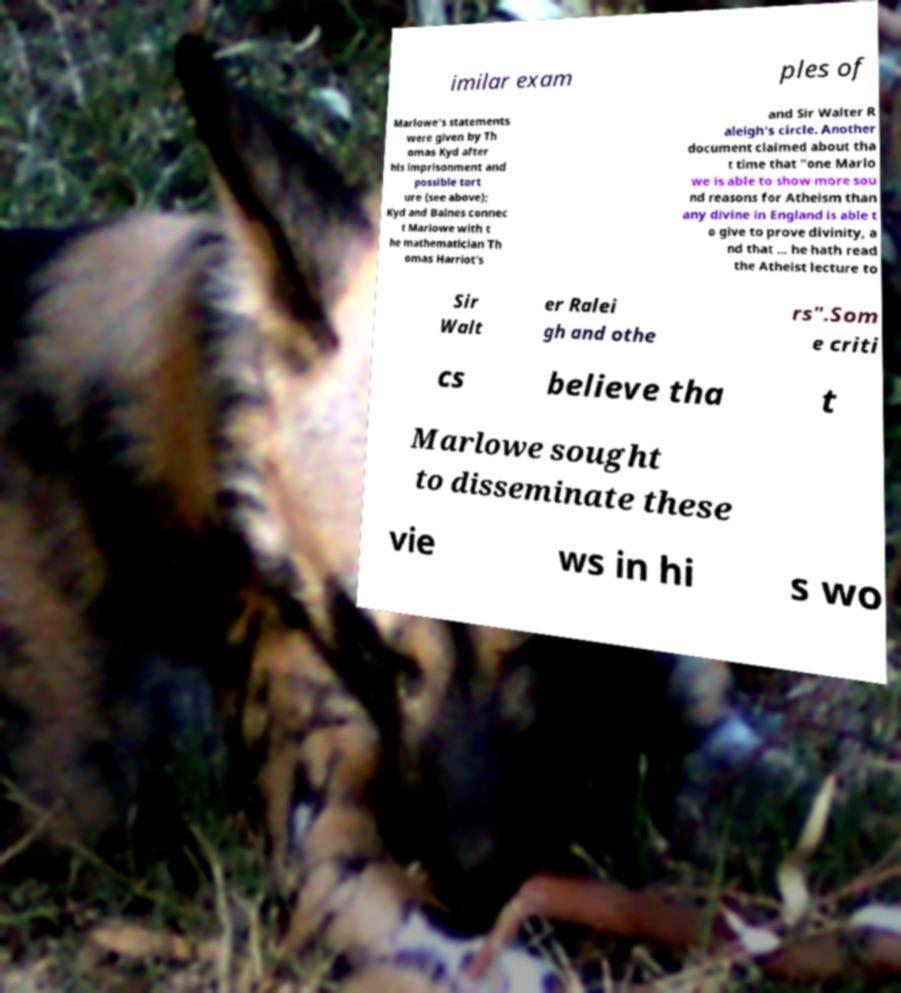Can you accurately transcribe the text from the provided image for me? imilar exam ples of Marlowe's statements were given by Th omas Kyd after his imprisonment and possible tort ure (see above); Kyd and Baines connec t Marlowe with t he mathematician Th omas Harriot's and Sir Walter R aleigh's circle. Another document claimed about tha t time that "one Marlo we is able to show more sou nd reasons for Atheism than any divine in England is able t o give to prove divinity, a nd that ... he hath read the Atheist lecture to Sir Walt er Ralei gh and othe rs".Som e criti cs believe tha t Marlowe sought to disseminate these vie ws in hi s wo 